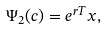Convert formula to latex. <formula><loc_0><loc_0><loc_500><loc_500>\Psi _ { 2 } ( c ) = e ^ { r T } x ,</formula> 